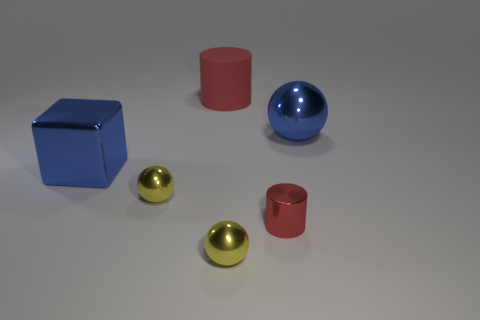Subtract all big blue shiny balls. How many balls are left? 2 Subtract all purple spheres. Subtract all cyan cylinders. How many spheres are left? 3 Add 3 cylinders. How many objects exist? 9 Subtract all cylinders. How many objects are left? 4 Subtract all small red metallic things. Subtract all small yellow cubes. How many objects are left? 5 Add 6 large blue shiny things. How many large blue shiny things are left? 8 Add 3 red metallic things. How many red metallic things exist? 4 Subtract 0 brown blocks. How many objects are left? 6 